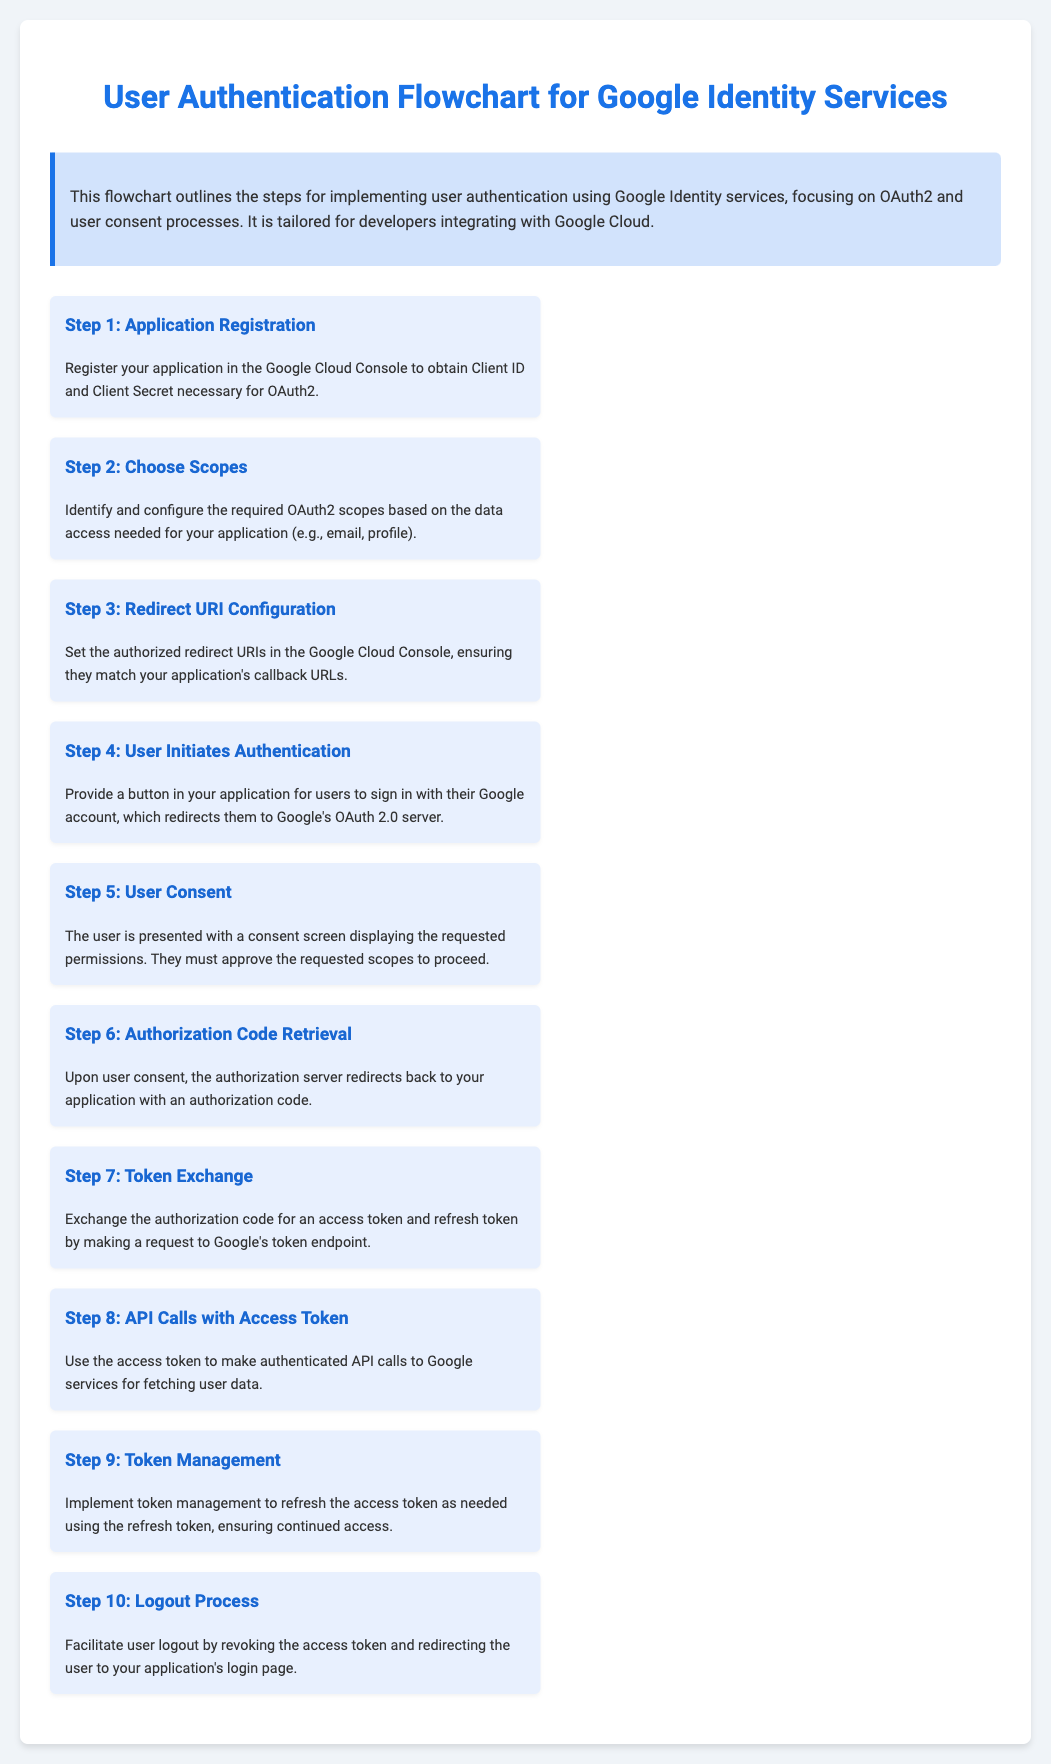What is the first step in the user authentication flow? The first step is Application Registration, where the application is registered in the Google Cloud Console.
Answer: Application Registration What is required to initiate user authentication? Users initiate authentication by clicking a button in the application that redirects them to Google's OAuth 2.0 server.
Answer: Button Which step involves user consent? Step 5 is where the user is presented with a consent screen displaying the requested permissions.
Answer: Step 5 How many steps are there in the flowchart? The flowchart consists of ten steps outlining the user authentication process.
Answer: Ten What do you obtain during Step 7? During Step 7, you exchange the authorization code for access and refresh tokens.
Answer: Access token and refresh token What is the purpose of the access token? The access token is used to make authenticated API calls to Google services for fetching user data.
Answer: Authenticated API calls What is the final step in the authentication flow? The final step is the Logout Process, which involves revoking the access token and redirecting to the login page.
Answer: Logout Process What is outlined in the overview section? The overview section summarizes the steps for implementing user authentication using Google Identity services.
Answer: Steps for implementing user authentication Which service is used for user authentication? Google Identity services are used for user authentication, specifically through OAuth2.
Answer: Google Identity services What do you need to configure based on data access? Required OAuth2 scopes need to be identified and configured in accordance with the data access needed for the application.
Answer: OAuth2 scopes 